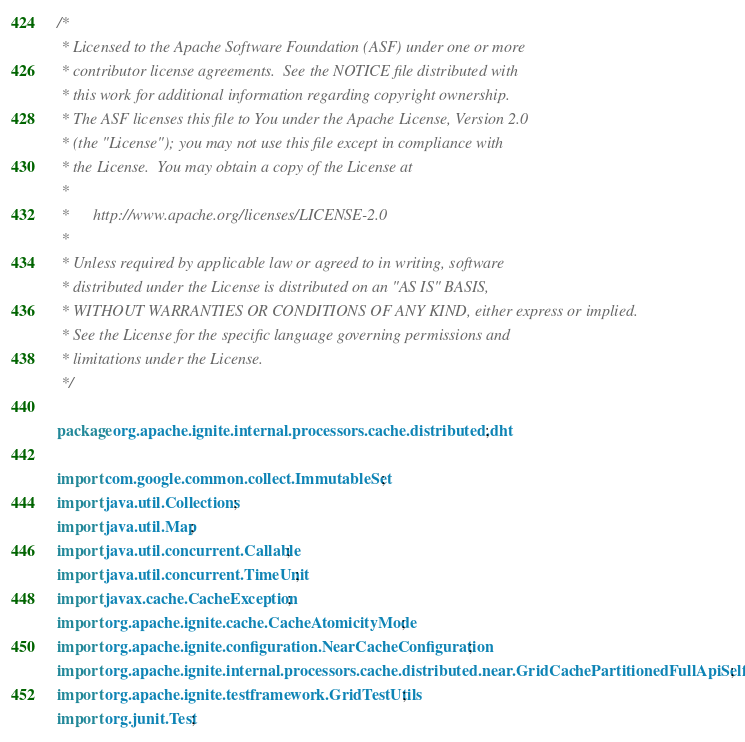<code> <loc_0><loc_0><loc_500><loc_500><_Java_>/*
 * Licensed to the Apache Software Foundation (ASF) under one or more
 * contributor license agreements.  See the NOTICE file distributed with
 * this work for additional information regarding copyright ownership.
 * The ASF licenses this file to You under the Apache License, Version 2.0
 * (the "License"); you may not use this file except in compliance with
 * the License.  You may obtain a copy of the License at
 *
 *      http://www.apache.org/licenses/LICENSE-2.0
 *
 * Unless required by applicable law or agreed to in writing, software
 * distributed under the License is distributed on an "AS IS" BASIS,
 * WITHOUT WARRANTIES OR CONDITIONS OF ANY KIND, either express or implied.
 * See the License for the specific language governing permissions and
 * limitations under the License.
 */

package org.apache.ignite.internal.processors.cache.distributed.dht;

import com.google.common.collect.ImmutableSet;
import java.util.Collections;
import java.util.Map;
import java.util.concurrent.Callable;
import java.util.concurrent.TimeUnit;
import javax.cache.CacheException;
import org.apache.ignite.cache.CacheAtomicityMode;
import org.apache.ignite.configuration.NearCacheConfiguration;
import org.apache.ignite.internal.processors.cache.distributed.near.GridCachePartitionedFullApiSelfTest;
import org.apache.ignite.testframework.GridTestUtils;
import org.junit.Test;
</code> 